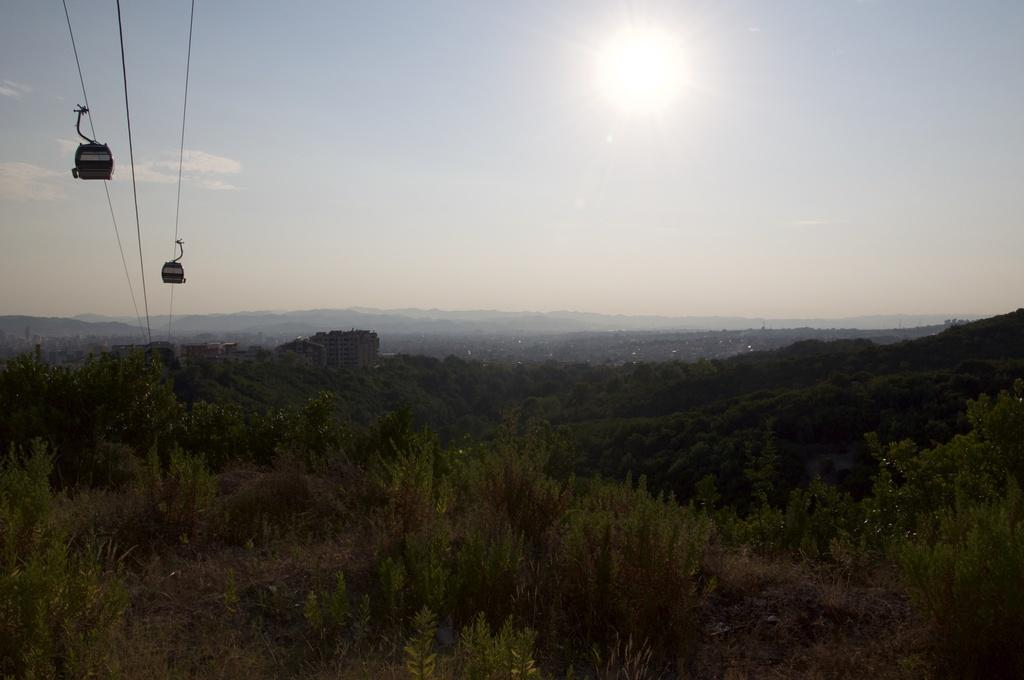What type of vegetation is visible in the image? There are trees in the image. What are the ropes used for in the image? The ropes are used for sky rides in the image. What can be seen in the background of the image? There are buildings visible in the background of the image. What is visible in the sky in the image? The sky is visible in the background of the image. Where are the vases placed in the image? There are no vases present in the image. What type of tool is being used to build the buildings in the image? The provided facts do not mention any tools being used to build the buildings in the image. How many beds can be seen in the image? There are no beds present in the image. 